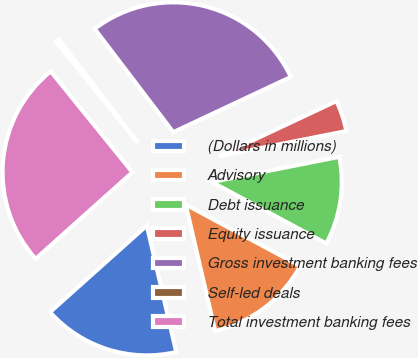Convert chart. <chart><loc_0><loc_0><loc_500><loc_500><pie_chart><fcel>(Dollars in millions)<fcel>Advisory<fcel>Debt issuance<fcel>Equity issuance<fcel>Gross investment banking fees<fcel>Self-led deals<fcel>Total investment banking fees<nl><fcel>17.02%<fcel>13.52%<fcel>10.95%<fcel>3.88%<fcel>28.36%<fcel>0.48%<fcel>25.78%<nl></chart> 